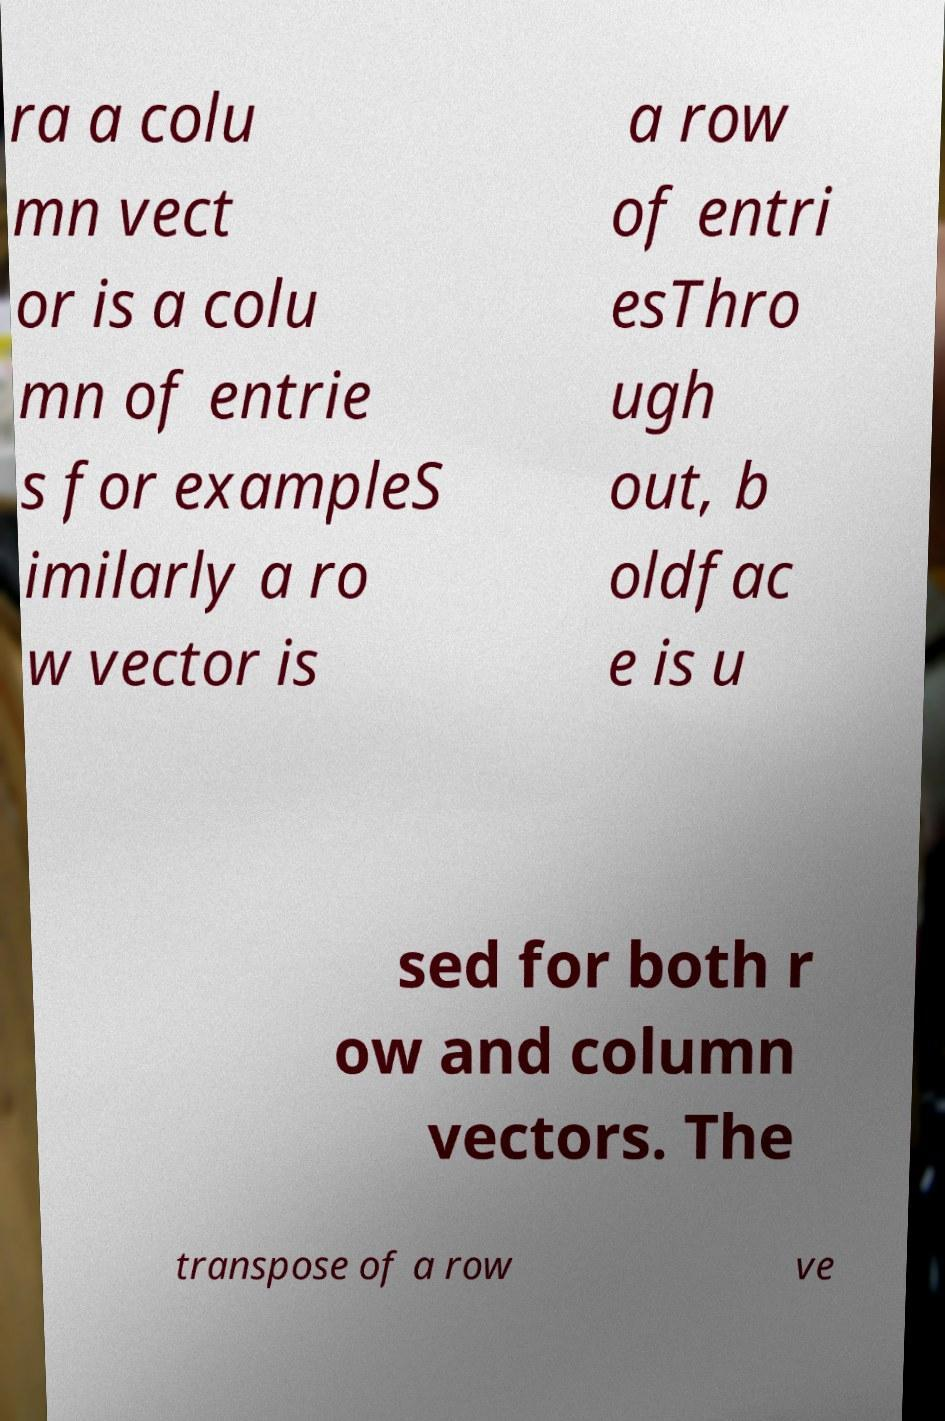Can you read and provide the text displayed in the image?This photo seems to have some interesting text. Can you extract and type it out for me? ra a colu mn vect or is a colu mn of entrie s for exampleS imilarly a ro w vector is a row of entri esThro ugh out, b oldfac e is u sed for both r ow and column vectors. The transpose of a row ve 